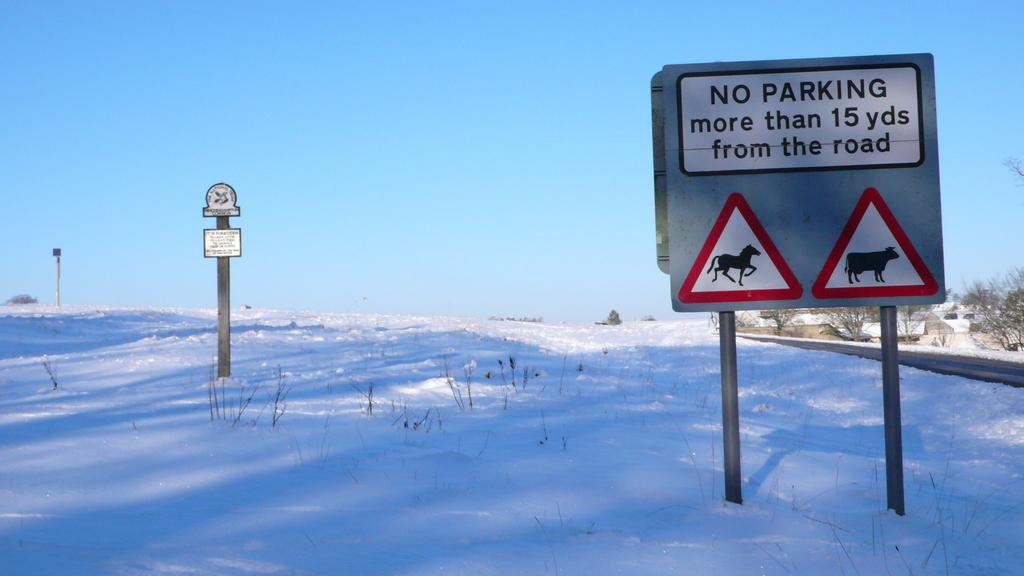<image>
Summarize the visual content of the image. Two triangle shaped signs, with a horse and cow on them, are underneath a larger sign, informing drivers not to park more than 15 yards from the road. 